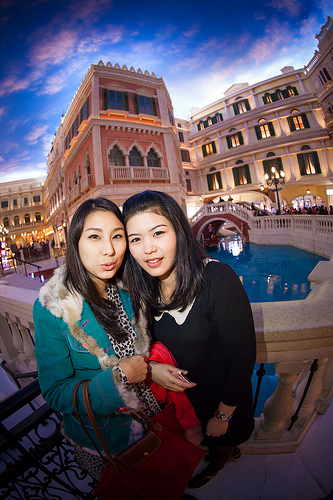<image>
Can you confirm if the lights is in the house? Yes. The lights is contained within or inside the house, showing a containment relationship. 